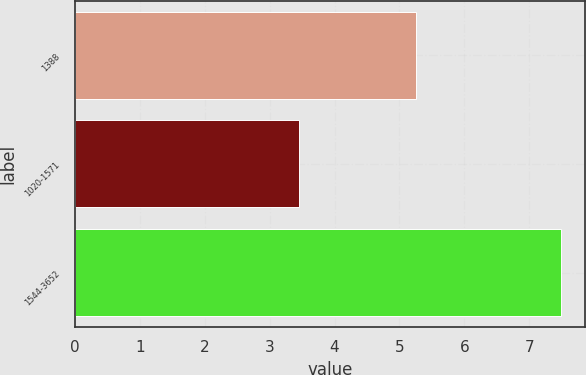Convert chart to OTSL. <chart><loc_0><loc_0><loc_500><loc_500><bar_chart><fcel>1388<fcel>1020-1571<fcel>1544-3652<nl><fcel>5.25<fcel>3.45<fcel>7.49<nl></chart> 